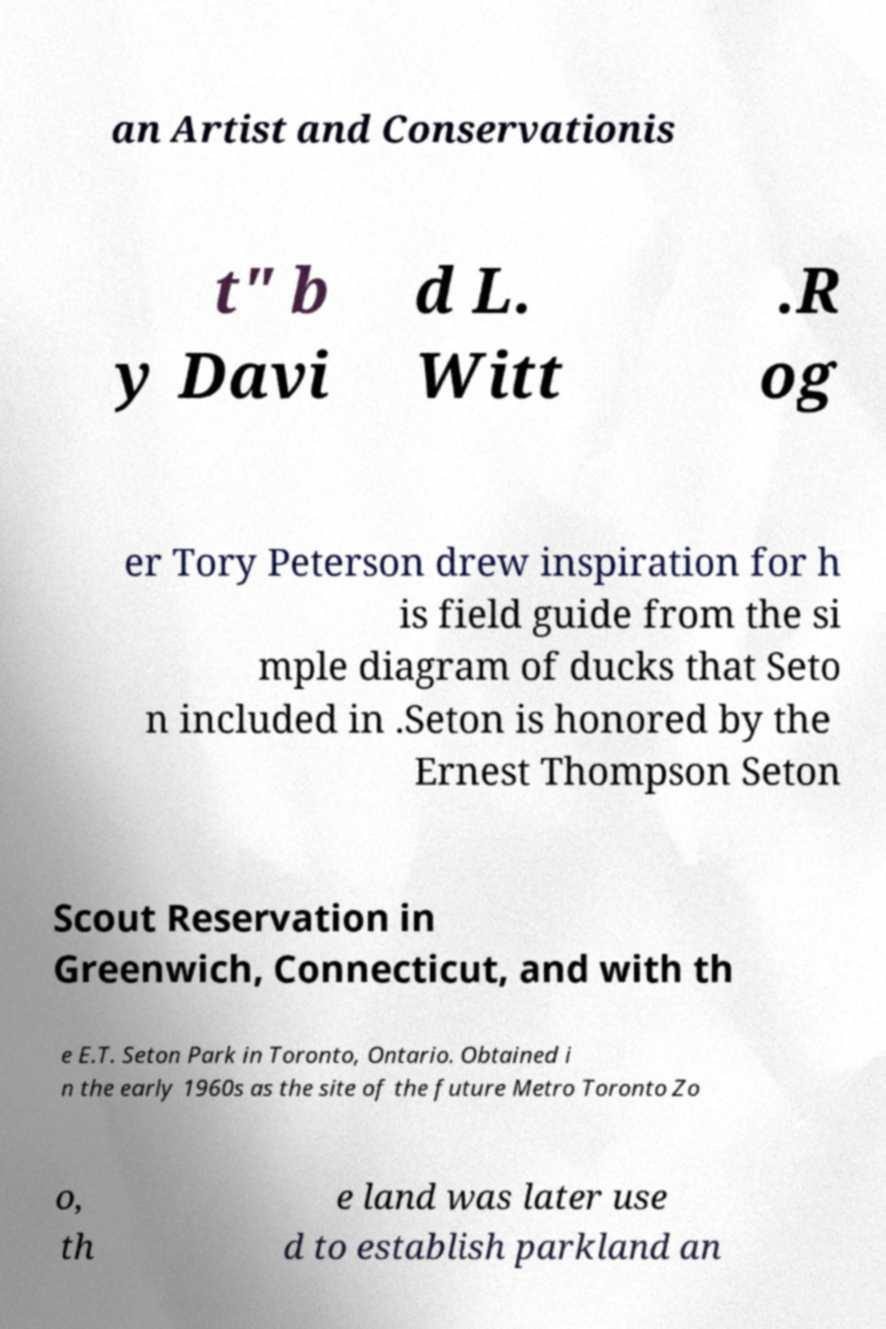Please identify and transcribe the text found in this image. an Artist and Conservationis t" b y Davi d L. Witt .R og er Tory Peterson drew inspiration for h is field guide from the si mple diagram of ducks that Seto n included in .Seton is honored by the Ernest Thompson Seton Scout Reservation in Greenwich, Connecticut, and with th e E.T. Seton Park in Toronto, Ontario. Obtained i n the early 1960s as the site of the future Metro Toronto Zo o, th e land was later use d to establish parkland an 